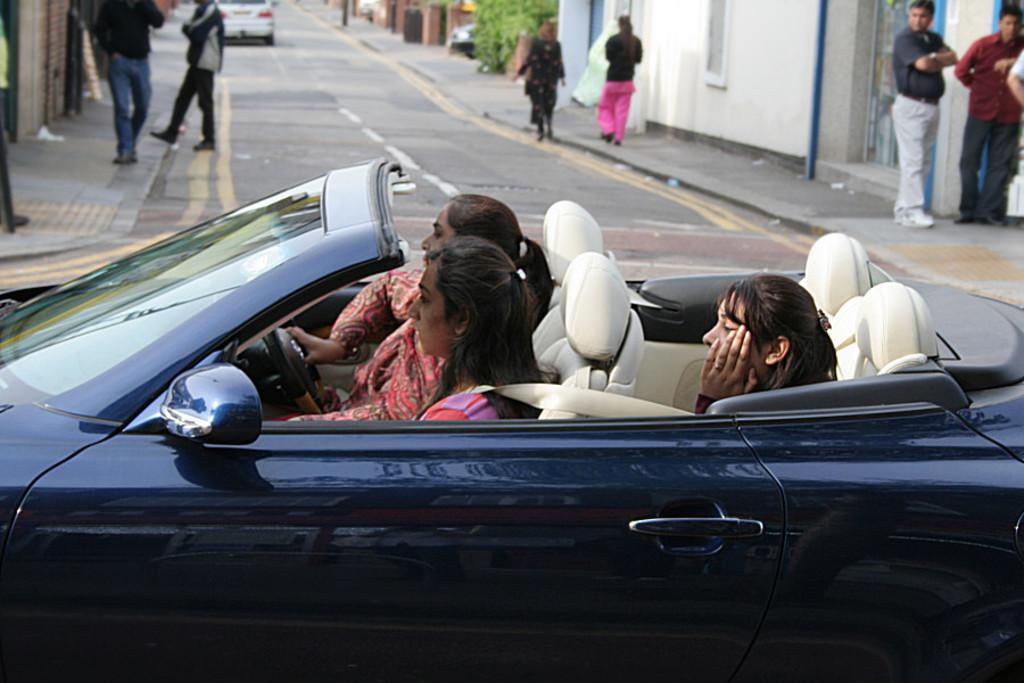How many women are in the car in the image? There are three women in the car in the image. What are the women doing in the car? The women are seated in the car. What can be seen on both sides of the road in the image? There are several humans walking on the right side of the road and several humans walking on the left side of the road. What type of tin can be seen in the hands of the beggar in the image? There is no beggar or tin present in the image. What are the women reading in the car in the image? There is no reading material or activity mentioned in the image; the women are simply seated in the car. 